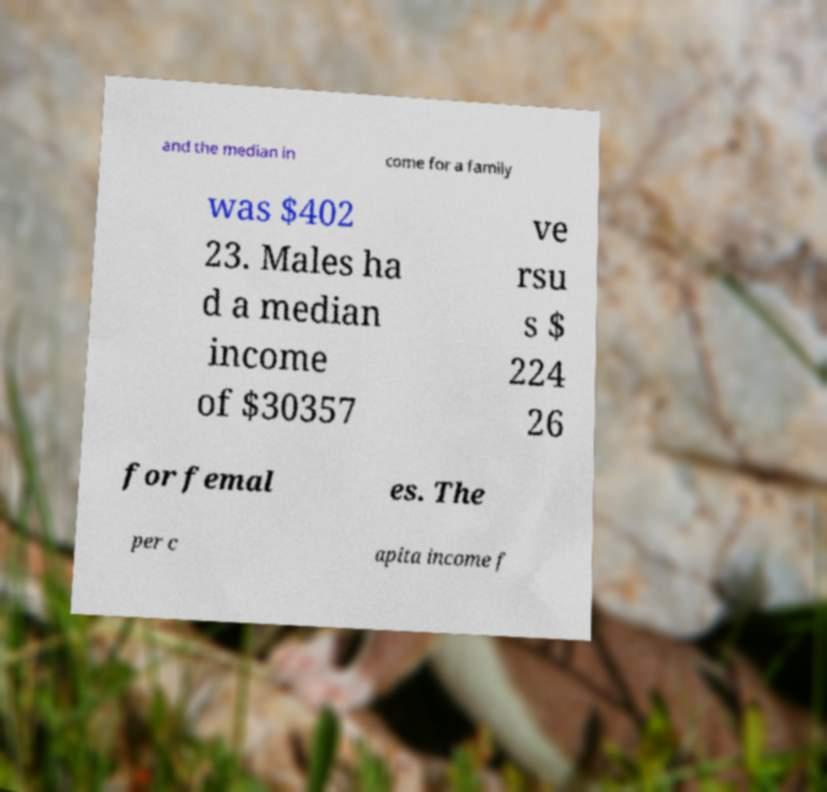Please read and relay the text visible in this image. What does it say? and the median in come for a family was $402 23. Males ha d a median income of $30357 ve rsu s $ 224 26 for femal es. The per c apita income f 